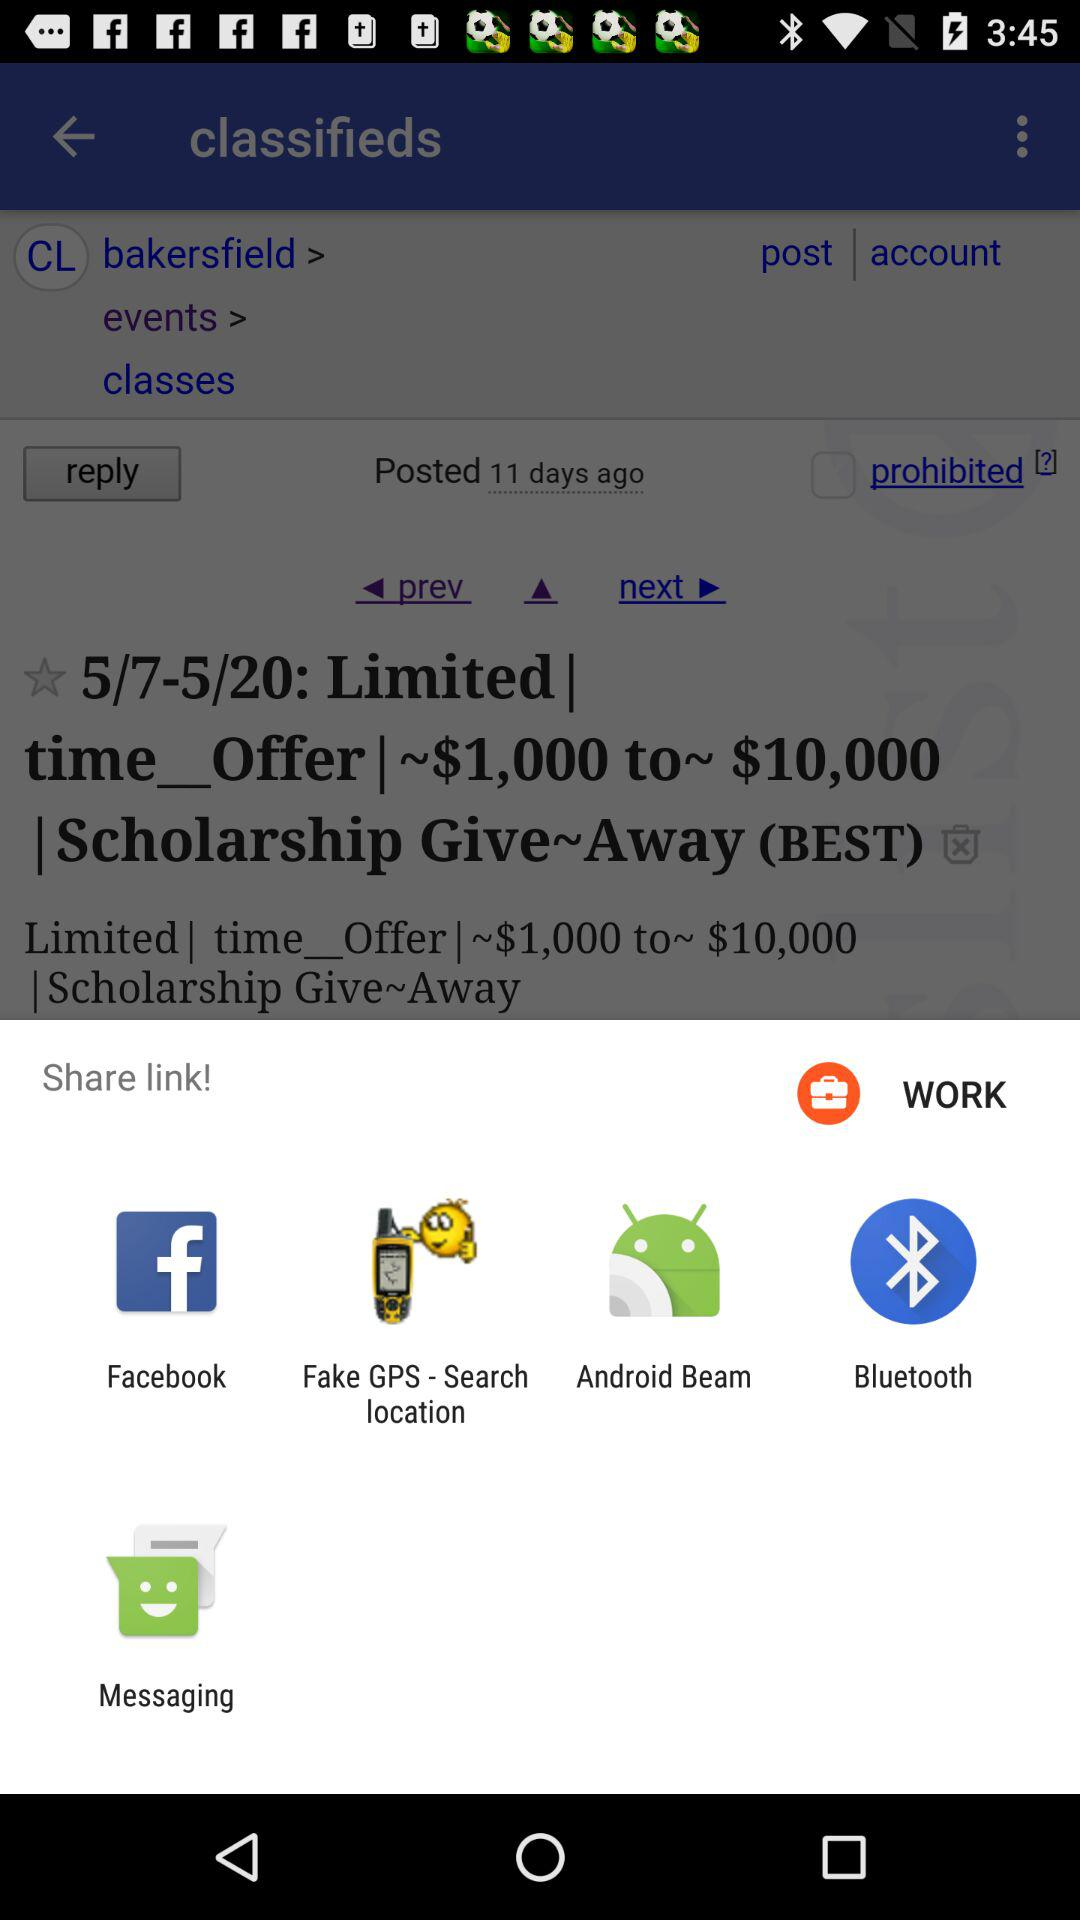From which app can we share? You can share from "Facebook", "Fake GPS - Search location", "Android Beam", "Bluetooth" and "Messaging". 